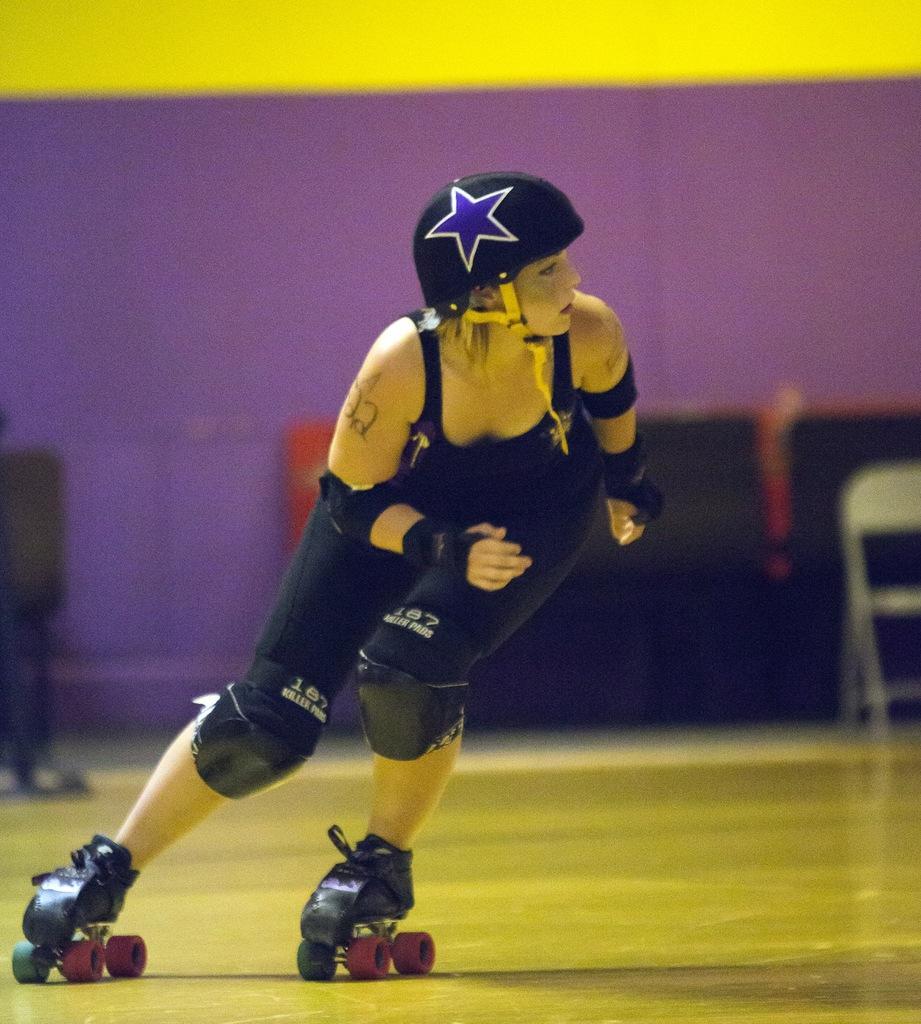How would you summarize this image in a sentence or two? In this image there is a person with a helmet doing skating with the skating shoes ,and in the background there is chair and a wall. 